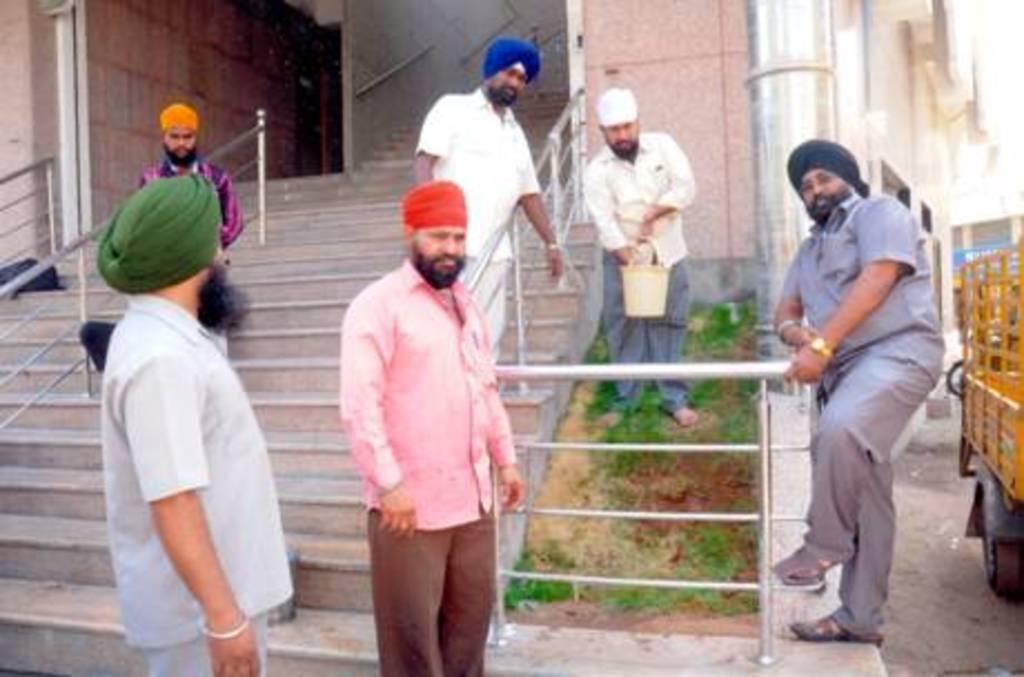Please provide a concise description of this image. There are people standing and this man holding a bucket. We can see plants, railings and steps. Behind this person we can see a vehicle. In the background we can see walls, building and pole. 